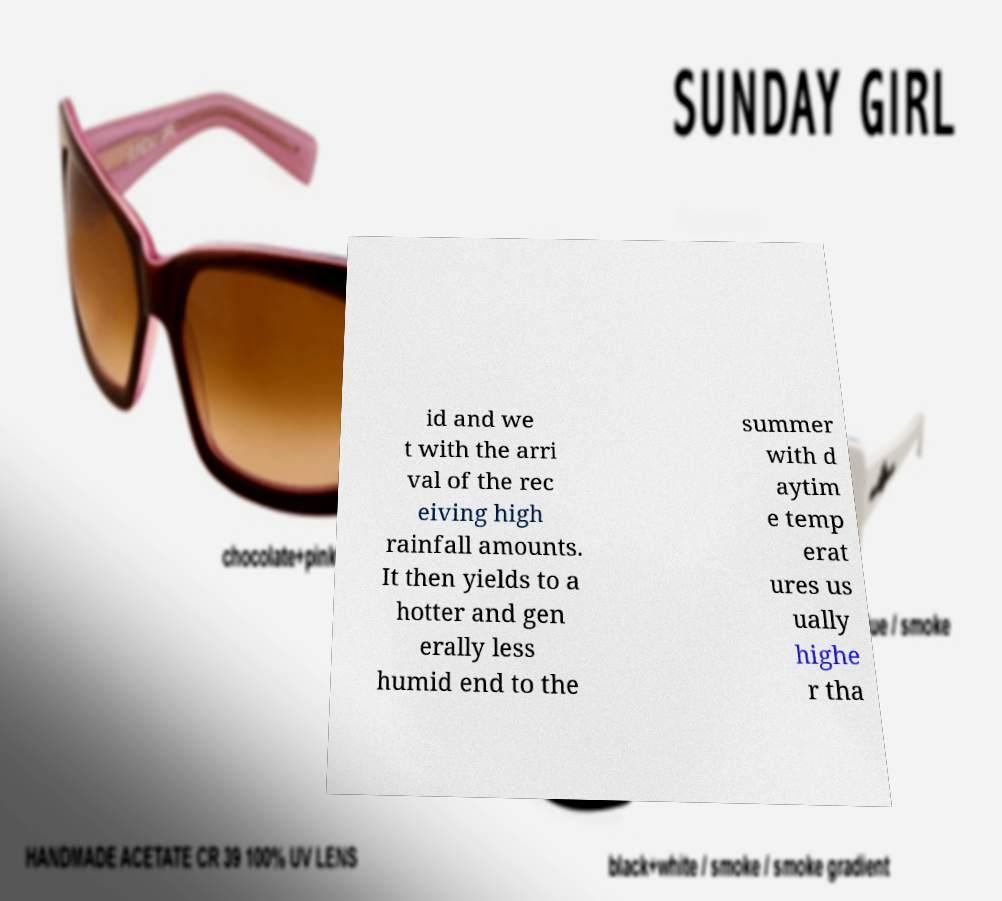Could you extract and type out the text from this image? id and we t with the arri val of the rec eiving high rainfall amounts. It then yields to a hotter and gen erally less humid end to the summer with d aytim e temp erat ures us ually highe r tha 